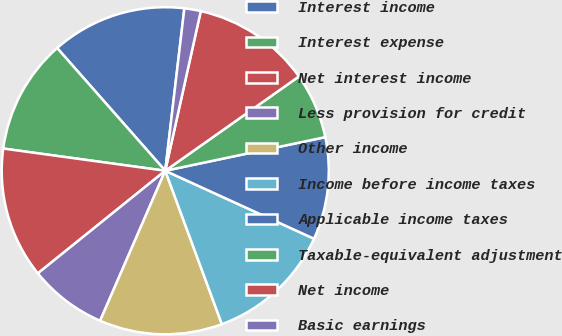Convert chart to OTSL. <chart><loc_0><loc_0><loc_500><loc_500><pie_chart><fcel>Interest income<fcel>Interest expense<fcel>Net interest income<fcel>Less provision for credit<fcel>Other income<fcel>Income before income taxes<fcel>Applicable income taxes<fcel>Taxable-equivalent adjustment<fcel>Net income<fcel>Basic earnings<nl><fcel>13.36%<fcel>11.34%<fcel>12.96%<fcel>7.69%<fcel>12.15%<fcel>12.55%<fcel>10.12%<fcel>6.48%<fcel>11.74%<fcel>1.62%<nl></chart> 